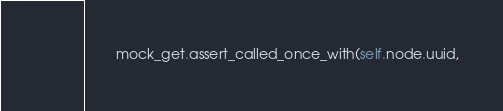<code> <loc_0><loc_0><loc_500><loc_500><_Python_>        mock_get.assert_called_once_with(self.node.uuid,</code> 